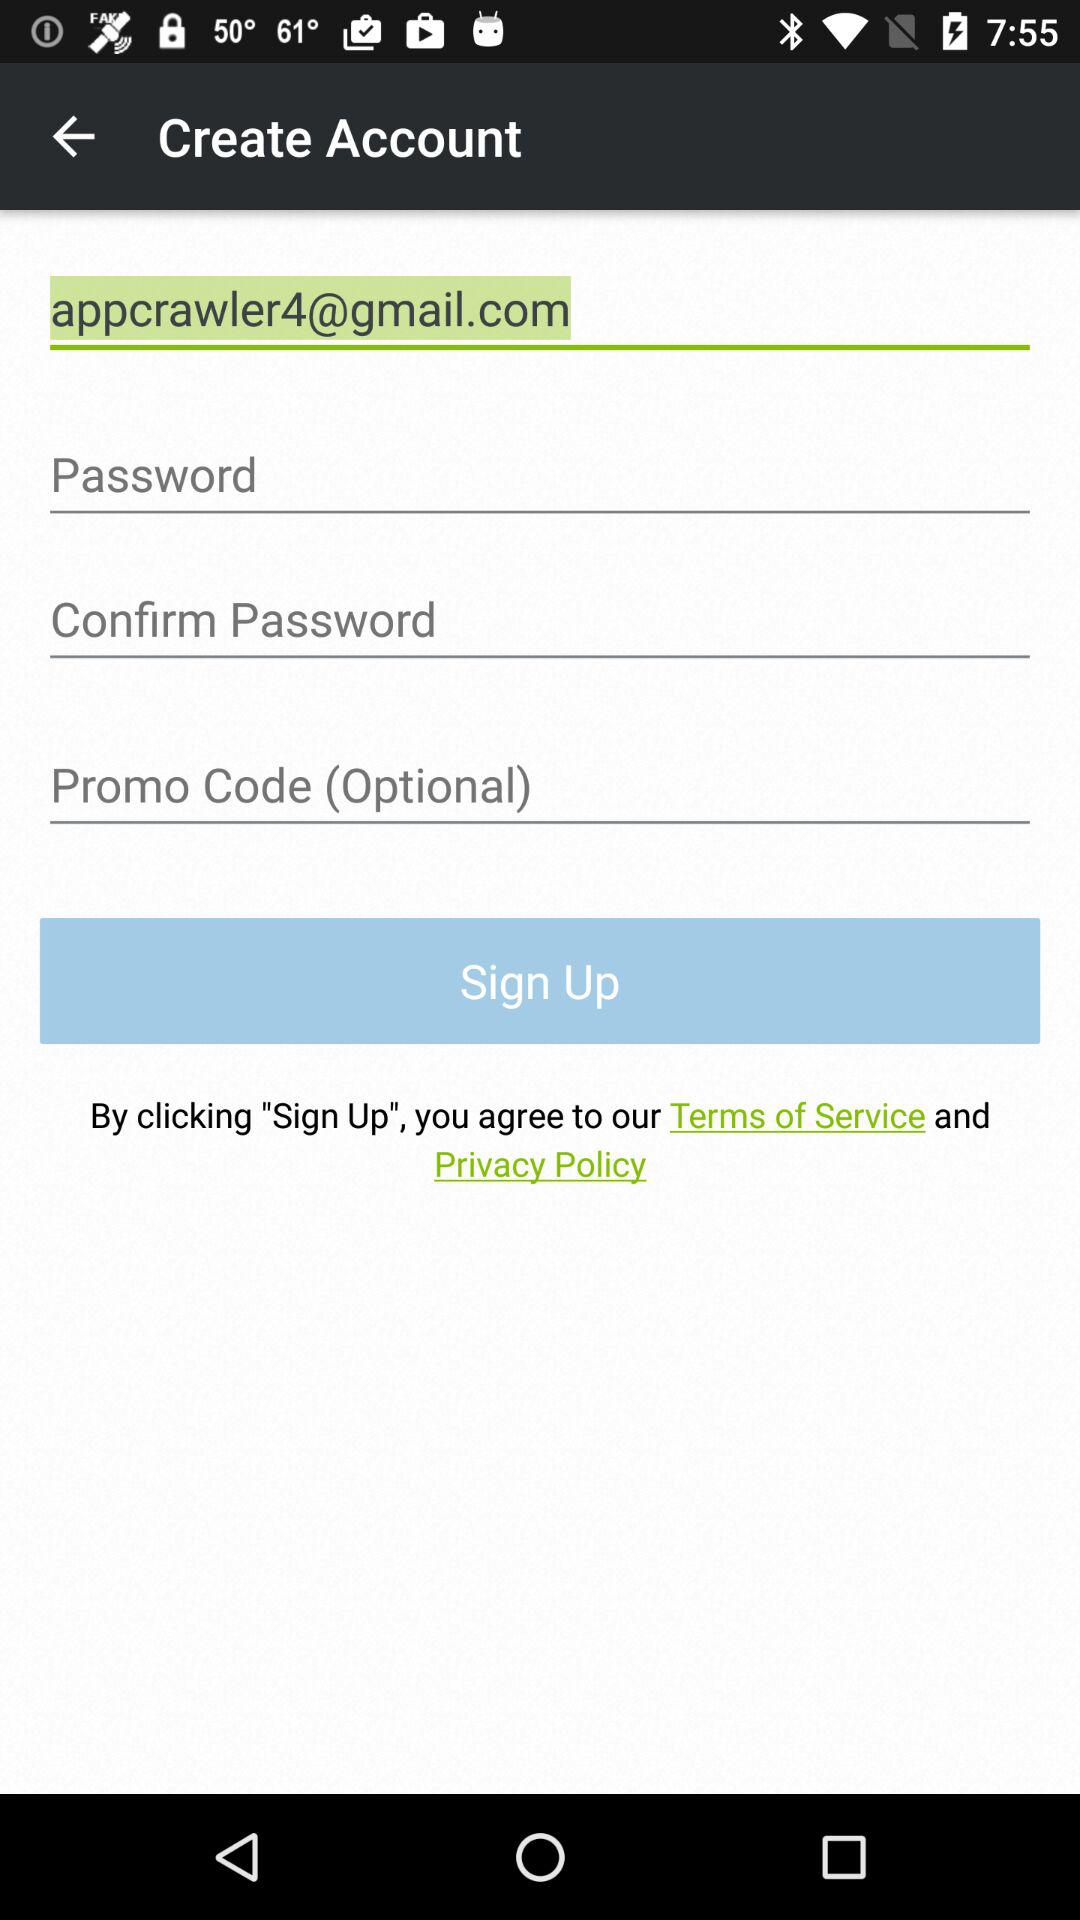What is the email address? The email address is appcrawler4@gmail.com. 